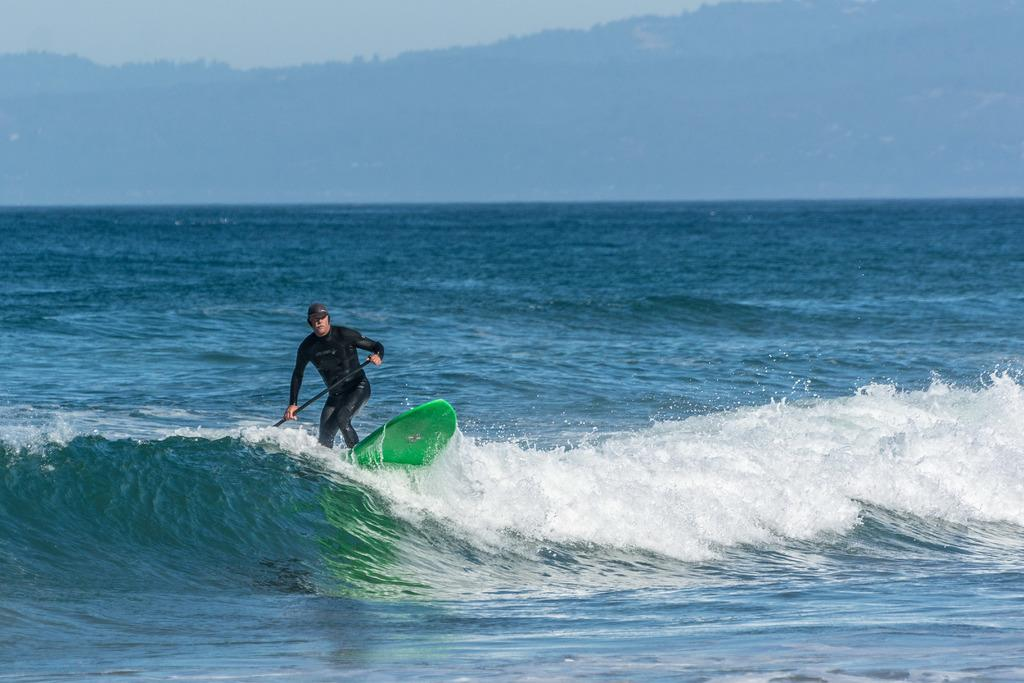What is the man in the image doing? The man is surfing with a surfboard. What is the man holding in the image? The man is holding a paddle. What is the primary setting of the image? There is water in the image. What can be seen in the background of the image? There is a hill and the sky visible in the background of the image. How many letters are inside the mailbox in the image? There is no mailbox present in the image. What is the man's emotional state after experiencing loss in the image? There is no indication of loss or any emotional state in the image. 